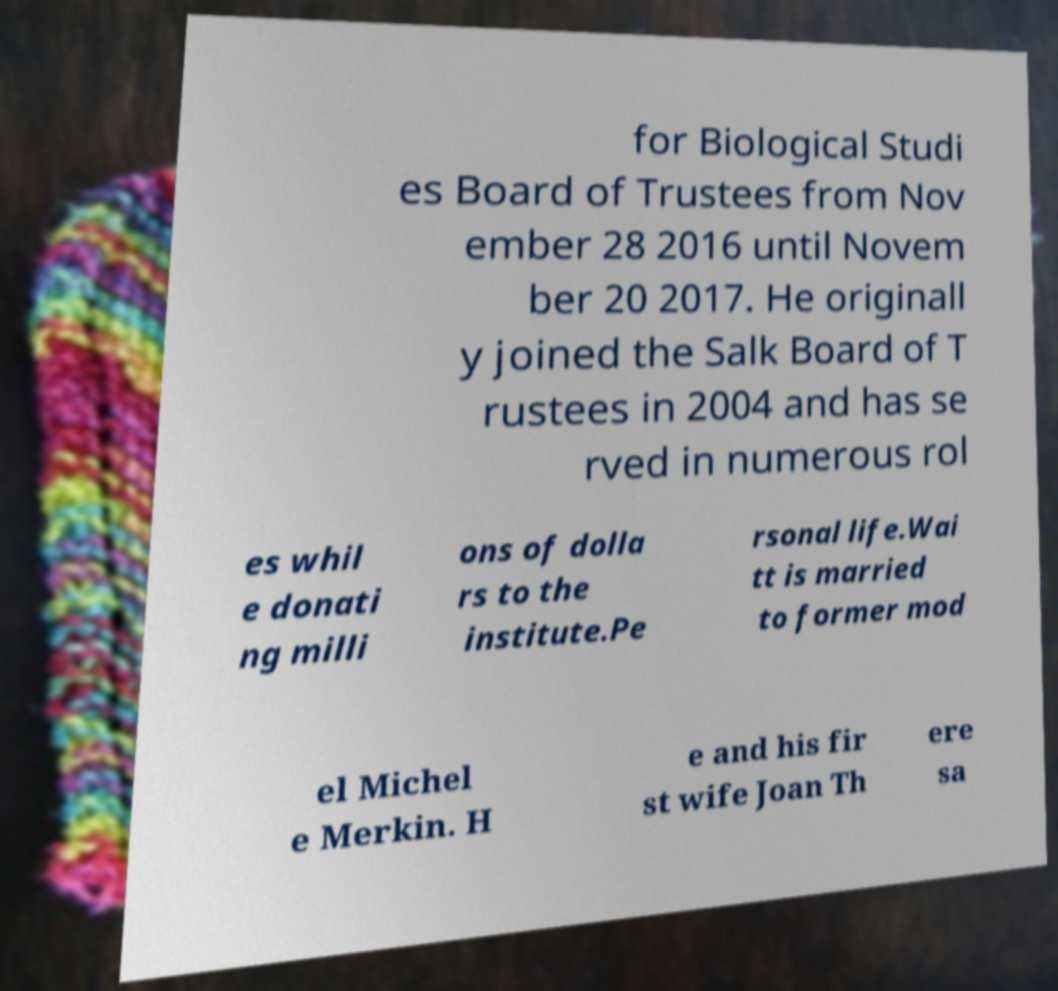For documentation purposes, I need the text within this image transcribed. Could you provide that? for Biological Studi es Board of Trustees from Nov ember 28 2016 until Novem ber 20 2017. He originall y joined the Salk Board of T rustees in 2004 and has se rved in numerous rol es whil e donati ng milli ons of dolla rs to the institute.Pe rsonal life.Wai tt is married to former mod el Michel e Merkin. H e and his fir st wife Joan Th ere sa 